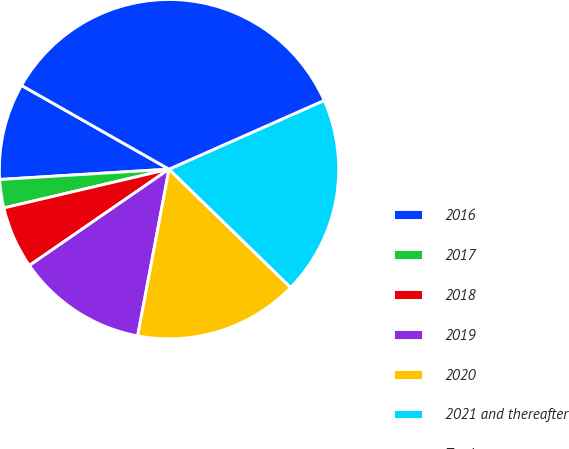Convert chart. <chart><loc_0><loc_0><loc_500><loc_500><pie_chart><fcel>2016<fcel>2017<fcel>2018<fcel>2019<fcel>2020<fcel>2021 and thereafter<fcel>Total<nl><fcel>9.19%<fcel>2.7%<fcel>5.94%<fcel>12.43%<fcel>15.68%<fcel>18.92%<fcel>35.14%<nl></chart> 